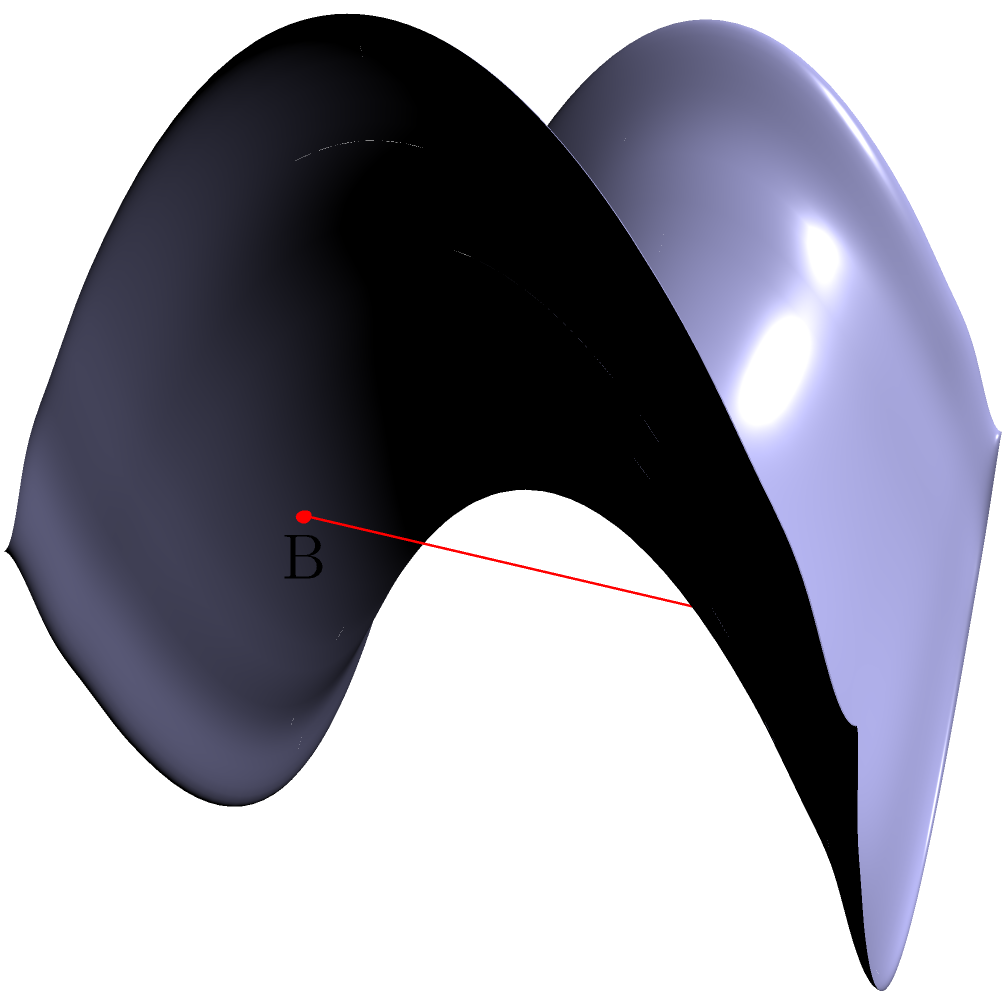Consider a triangle ABC drawn on a saddle-shaped surface as shown in the figure. If the sum of the interior angles of this triangle is 150°, what is the Gaussian curvature of the surface at the center of the triangle? (Assume the surface is uniformly curved in the vicinity of the triangle.) To solve this problem, we'll follow these steps:

1) Recall the Gauss-Bonnet theorem for a geodesic triangle on a curved surface:

   $$\alpha + \beta + \gamma = \pi + \int\int_A K dA$$

   where $\alpha$, $\beta$, and $\gamma$ are the interior angles, $A$ is the area of the triangle, and $K$ is the Gaussian curvature.

2) We're given that the sum of the interior angles is 150°. Convert this to radians:

   $$150° \cdot \frac{\pi}{180°} = \frac{5\pi}{6}$$

3) Substitute this into the Gauss-Bonnet theorem:

   $$\frac{5\pi}{6} = \pi + \int\int_A K dA$$

4) Simplify:

   $$-\frac{\pi}{6} = \int\int_A K dA$$

5) Assuming the curvature is uniform in the vicinity of the triangle, we can treat $K$ as constant:

   $$-\frac{\pi}{6} = K \cdot A$$

6) Solve for $K$:

   $$K = -\frac{\pi}{6A}$$

7) The question asks for the curvature at the center of the triangle, which is this uniform $K$ we've calculated.
Answer: $-\frac{\pi}{6A}$ 